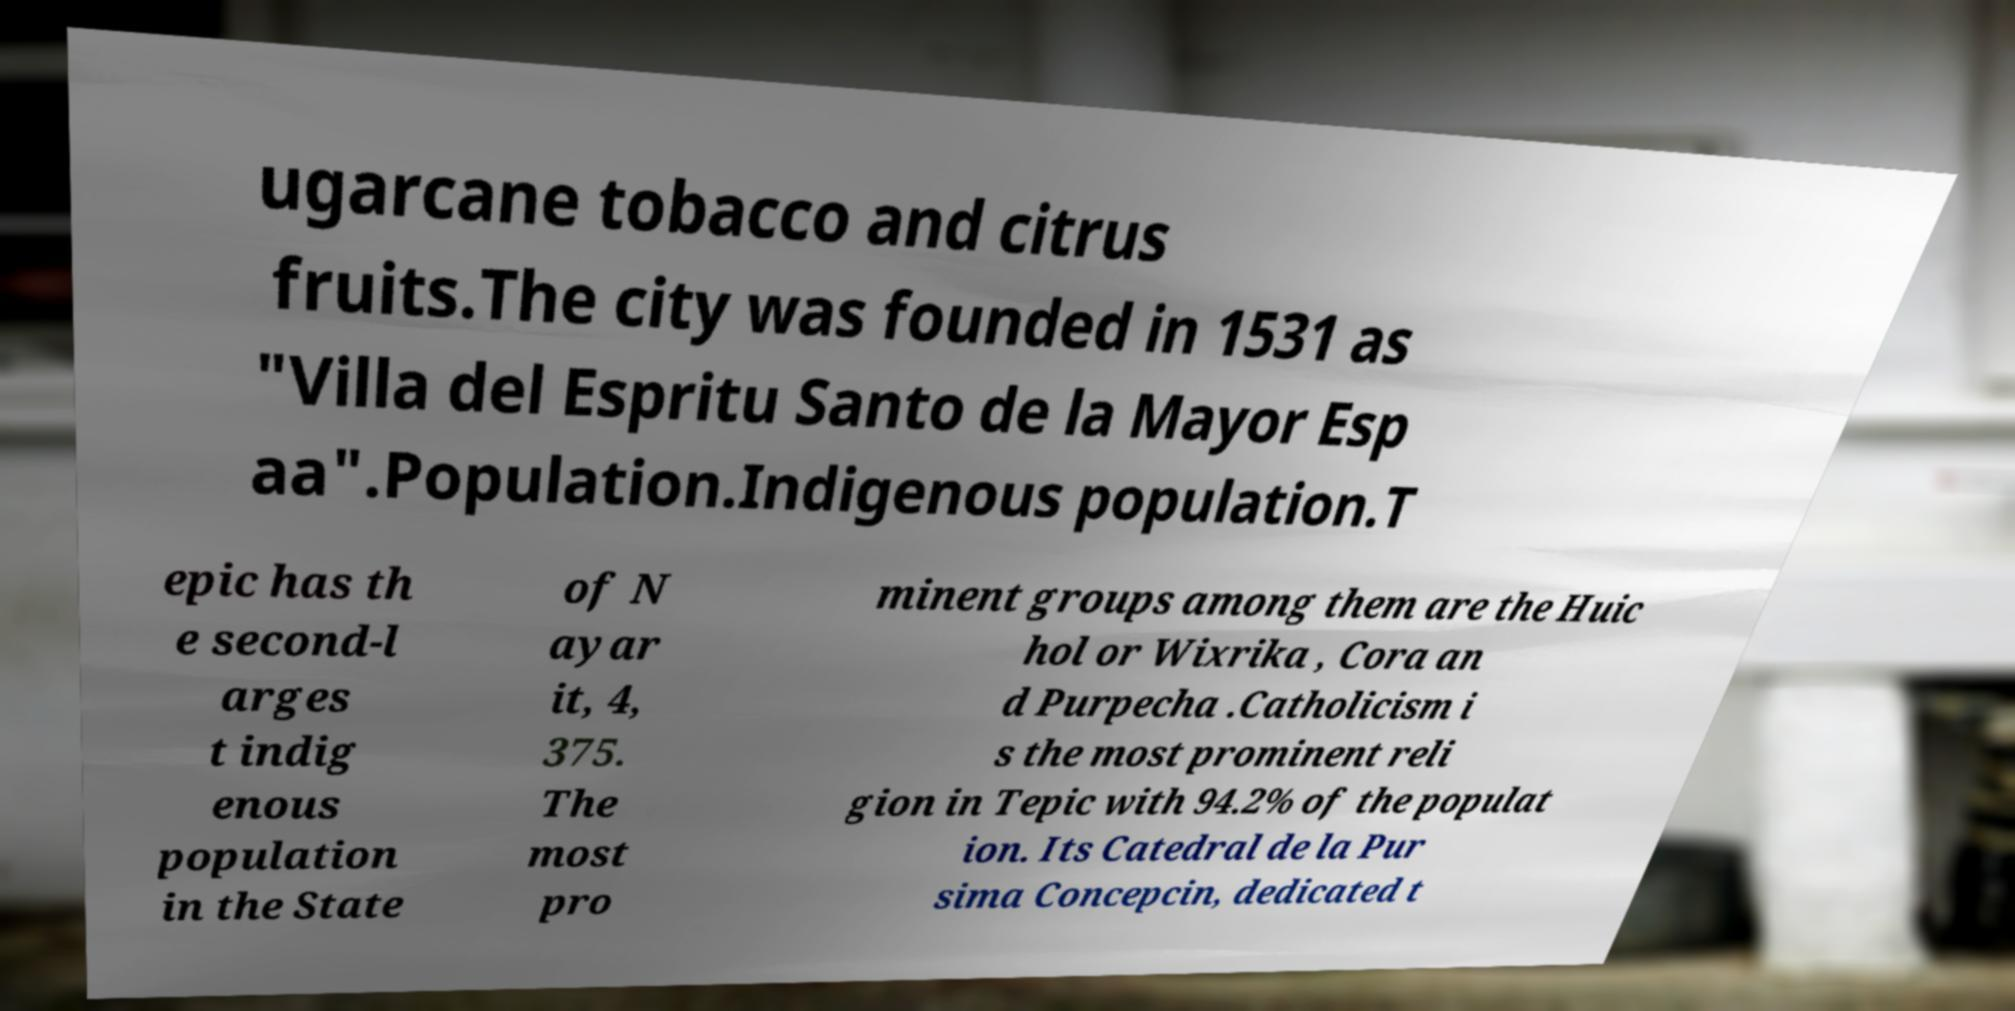Can you read and provide the text displayed in the image?This photo seems to have some interesting text. Can you extract and type it out for me? ugarcane tobacco and citrus fruits.The city was founded in 1531 as "Villa del Espritu Santo de la Mayor Esp aa".Population.Indigenous population.T epic has th e second-l arges t indig enous population in the State of N ayar it, 4, 375. The most pro minent groups among them are the Huic hol or Wixrika , Cora an d Purpecha .Catholicism i s the most prominent reli gion in Tepic with 94.2% of the populat ion. Its Catedral de la Pur sima Concepcin, dedicated t 